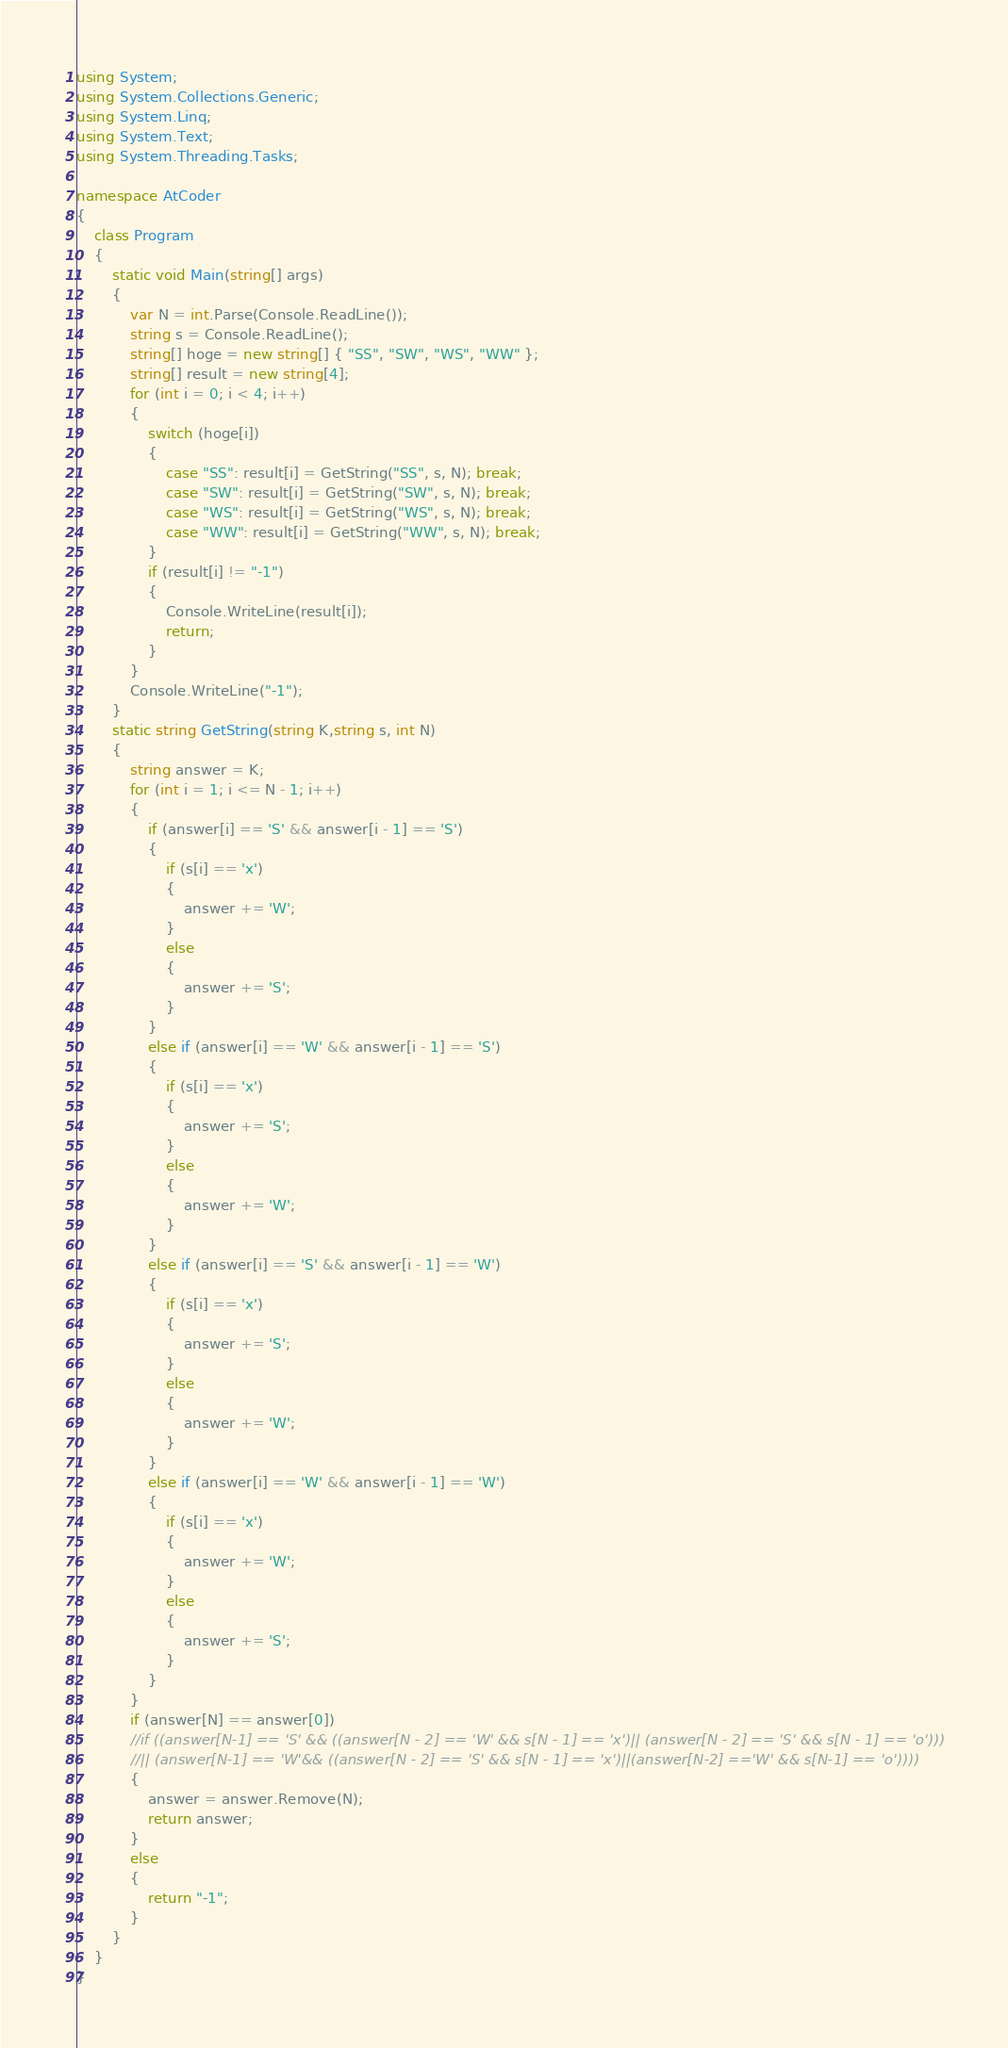<code> <loc_0><loc_0><loc_500><loc_500><_C#_>using System;
using System.Collections.Generic;
using System.Linq;
using System.Text;
using System.Threading.Tasks;

namespace AtCoder
{
	class Program
	{
		static void Main(string[] args)
		{
			var N = int.Parse(Console.ReadLine());
			string s = Console.ReadLine();
			string[] hoge = new string[] { "SS", "SW", "WS", "WW" };
			string[] result = new string[4];
			for (int i = 0; i < 4; i++)
			{
				switch (hoge[i])
				{
					case "SS": result[i] = GetString("SS", s, N); break;
					case "SW": result[i] = GetString("SW", s, N); break;
					case "WS": result[i] = GetString("WS", s, N); break;
					case "WW": result[i] = GetString("WW", s, N); break;
				}
				if (result[i] != "-1")
				{
					Console.WriteLine(result[i]);
					return;
				}
			}
			Console.WriteLine("-1");
		}
		static string GetString(string K,string s, int N)
		{
			string answer = K;
			for (int i = 1; i <= N - 1; i++)
			{
				if (answer[i] == 'S' && answer[i - 1] == 'S')
				{
					if (s[i] == 'x')
					{
						answer += 'W';
					}
					else
					{
						answer += 'S';
					}
				}
				else if (answer[i] == 'W' && answer[i - 1] == 'S')
				{
					if (s[i] == 'x')
					{
						answer += 'S';
					}
					else
					{
						answer += 'W';
					}
				}
				else if (answer[i] == 'S' && answer[i - 1] == 'W')
				{
					if (s[i] == 'x')
					{
						answer += 'S';
					}
					else
					{
						answer += 'W';
					}
				}
				else if (answer[i] == 'W' && answer[i - 1] == 'W')
				{
					if (s[i] == 'x')
					{
						answer += 'W';
					}
					else
					{
						answer += 'S';
					}
				}
			}
			if (answer[N] == answer[0])
			//if ((answer[N-1] == 'S' && ((answer[N - 2] == 'W' && s[N - 1] == 'x')|| (answer[N - 2] == 'S' && s[N - 1] == 'o')))
			//|| (answer[N-1] == 'W'&& ((answer[N - 2] == 'S' && s[N - 1] == 'x')||(answer[N-2] =='W' && s[N-1] == 'o'))))
			{
				answer = answer.Remove(N);
				return answer;
			}
			else
			{
				return "-1";
			}
		}
	}
}
</code> 